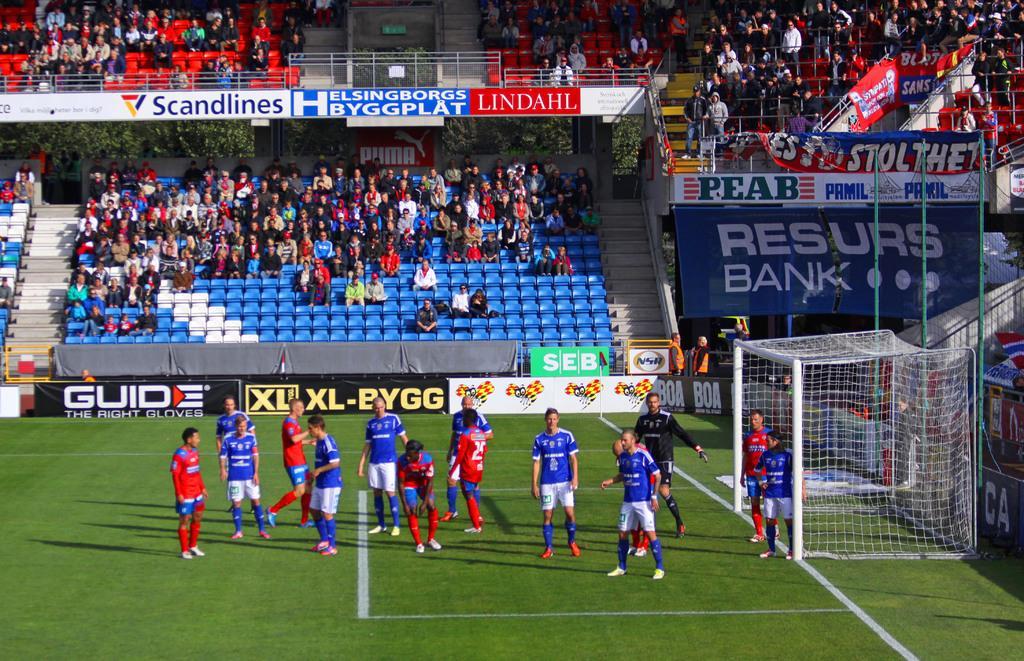Please provide a concise description of this image. In this picture I can see few players on the ground and I can see goal post and I can see few people are sitting in the chairs and I can see banners with some text and few advertisement boards with some text, it looks like a football ground. 